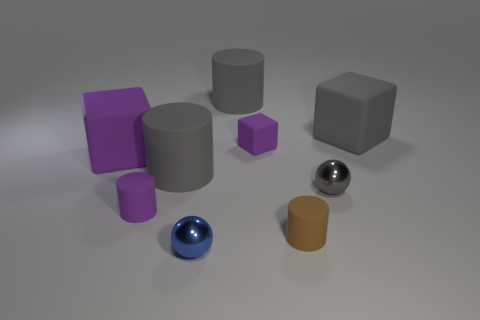Subtract all big gray rubber blocks. How many blocks are left? 2 Subtract all blue balls. How many balls are left? 1 Subtract 2 cylinders. How many cylinders are left? 2 Subtract all spheres. How many objects are left? 7 Subtract all brown cylinders. Subtract all purple spheres. How many cylinders are left? 3 Subtract all purple cylinders. How many purple blocks are left? 2 Subtract all big purple rubber cubes. Subtract all tiny gray objects. How many objects are left? 7 Add 1 blue metallic objects. How many blue metallic objects are left? 2 Add 7 tiny brown matte objects. How many tiny brown matte objects exist? 8 Subtract 1 gray spheres. How many objects are left? 8 